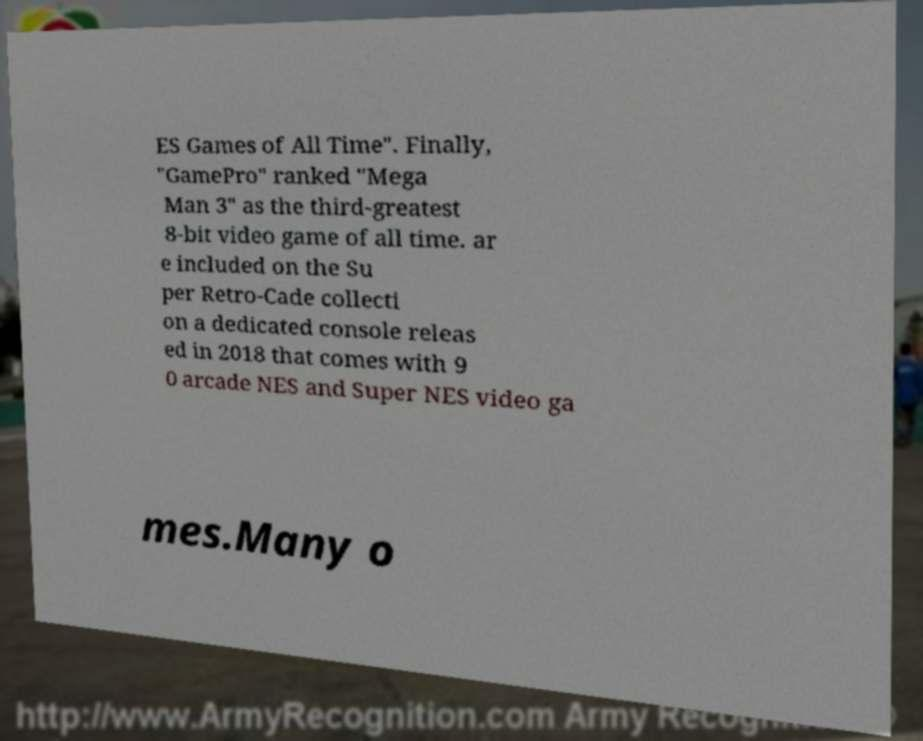Please identify and transcribe the text found in this image. ES Games of All Time". Finally, "GamePro" ranked "Mega Man 3" as the third-greatest 8-bit video game of all time. ar e included on the Su per Retro-Cade collecti on a dedicated console releas ed in 2018 that comes with 9 0 arcade NES and Super NES video ga mes.Many o 